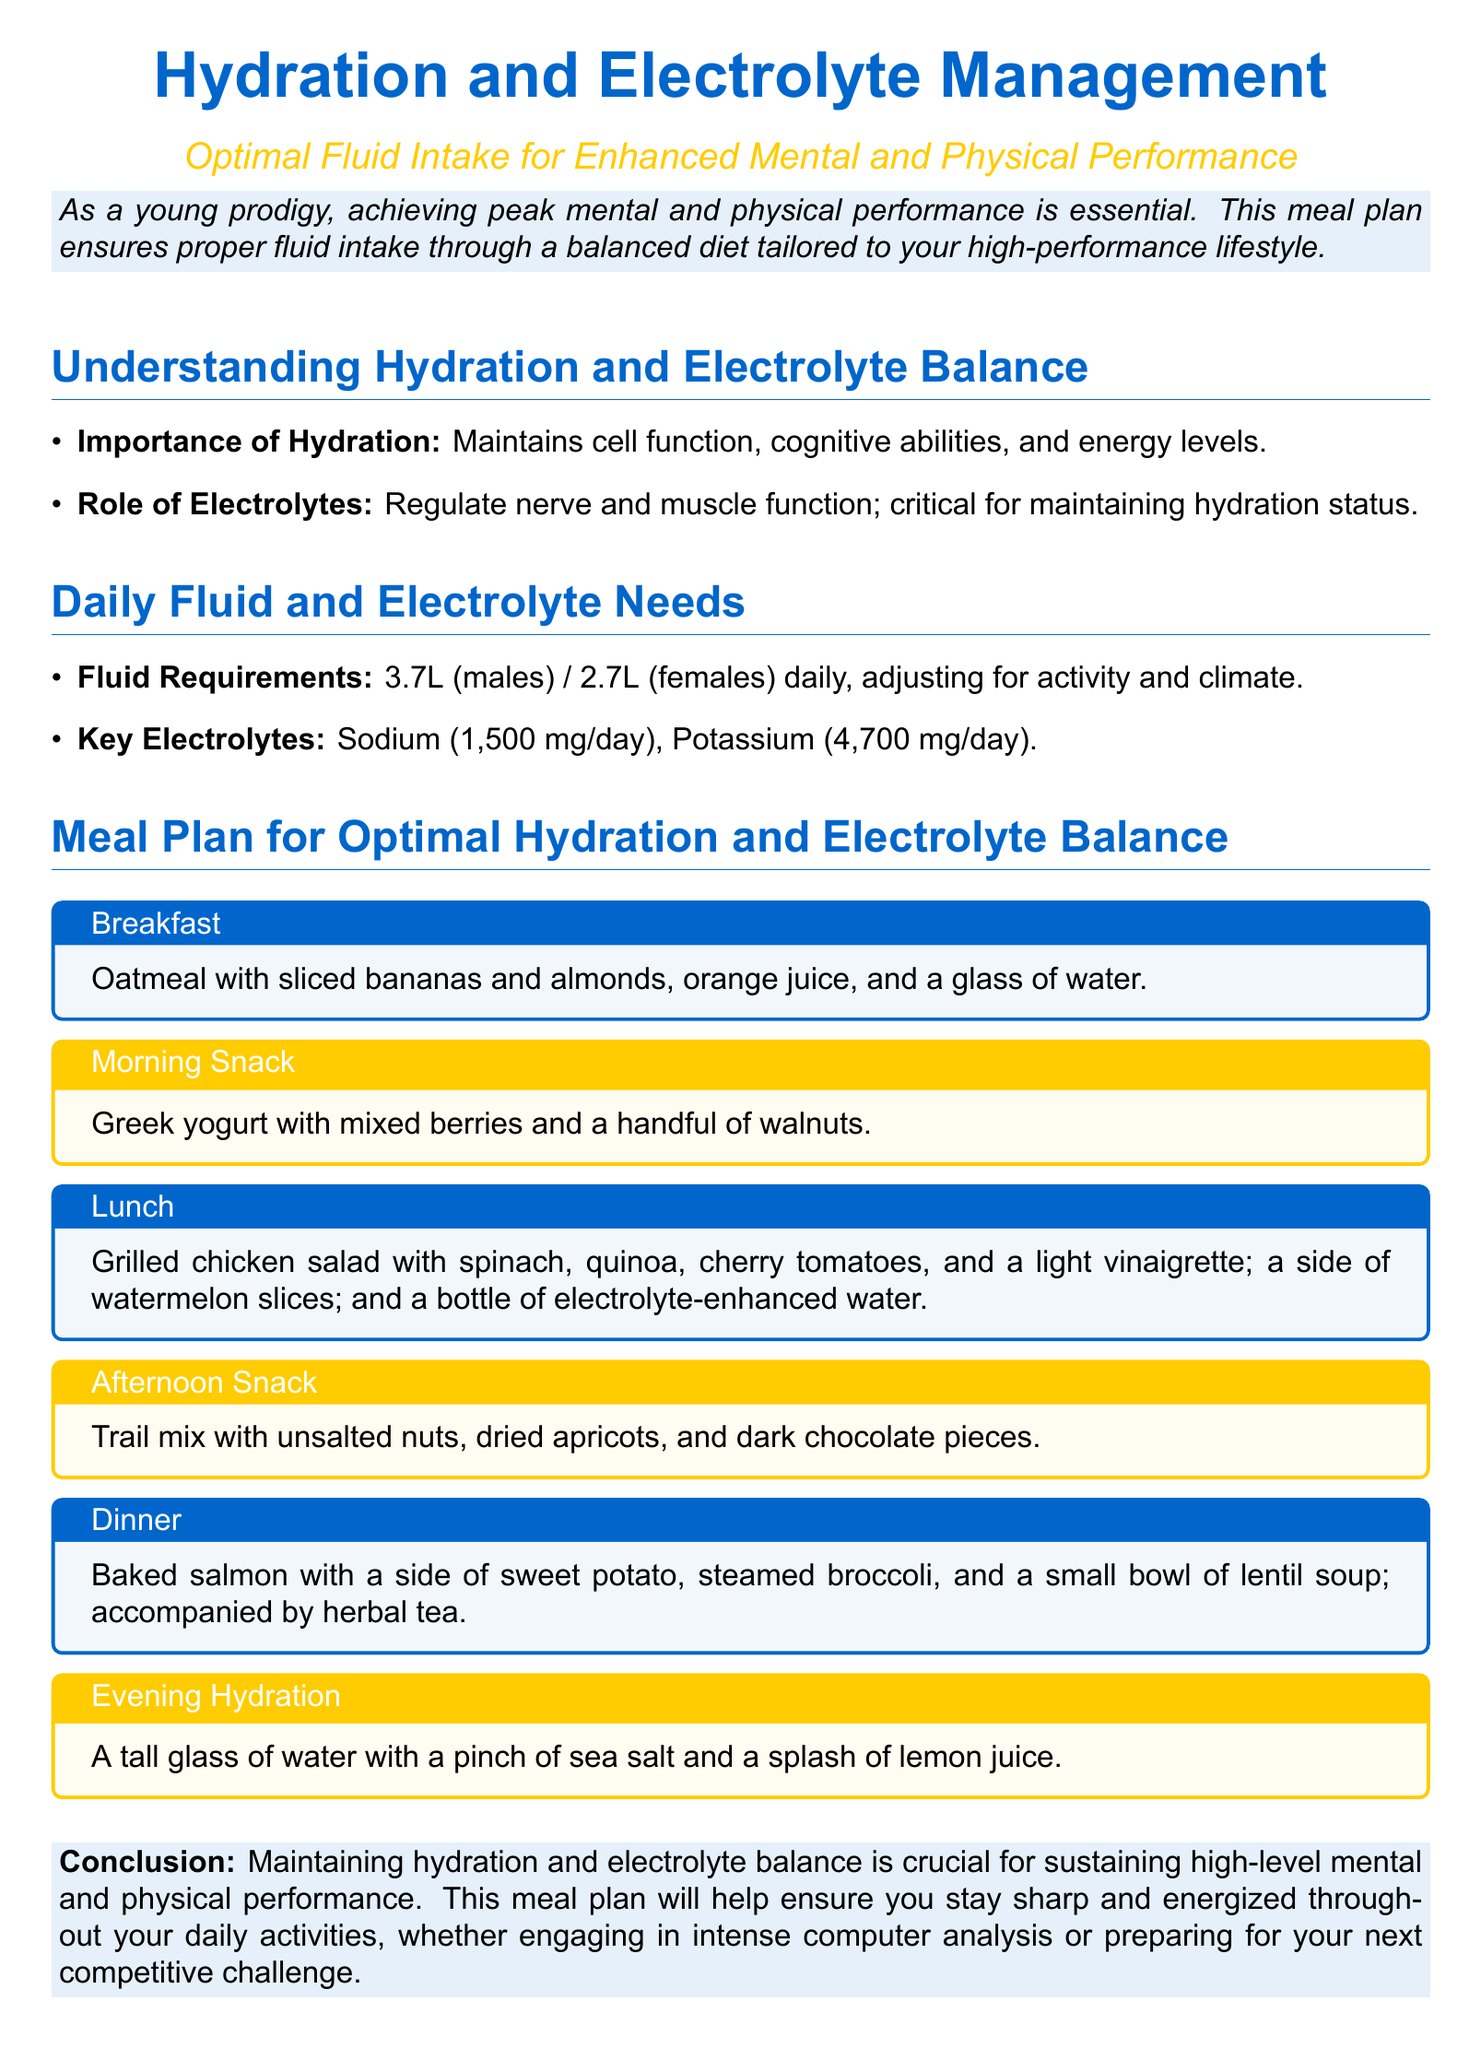What is the title of the meal plan? The title clearly stated at the beginning of the document is "Hydration and Electrolyte Management."
Answer: Hydration and Electrolyte Management What is the recommended daily fluid intake for males? The document specifies that males should aim for a fluid intake of 3.7 liters daily.
Answer: 3.7L What is one key electrolyte mentioned in the document? The document lists sodium and potassium as key electrolytes, with sodium being highlighted.
Answer: Sodium What does the breakfast meal consist of? The breakfast meal is outlined in the meal plan as oatmeal with sliced bananas and almonds, orange juice, and a glass of water.
Answer: Oatmeal with sliced bananas and almonds, orange juice, and a glass of water How much potassium is recommended per day? The daily requirement for potassium is stated explicitly in the document as 4,700 mg.
Answer: 4,700 mg What is suggested for afternoon snack? The document details that the afternoon snack consists of trail mix with unsalted nuts, dried apricots, and dark chocolate pieces.
Answer: Trail mix with unsalted nuts, dried apricots, and dark chocolate pieces What is the hydration recommendation for the evening? The evening hydration recommendation includes a tall glass of water with a pinch of sea salt and a splash of lemon juice.
Answer: A tall glass of water with a pinch of sea salt and a splash of lemon juice How is the dinner meal described in the plan? The dinner meal is a combination of baked salmon with a side of sweet potato, steamed broccoli, and a small bowl of lentil soup, along with herbal tea.
Answer: Baked salmon with a side of sweet potato, steamed broccoli, and lentil soup; herbal tea What is the significance of hydration according to the document? The document states that hydration maintains cell function, cognitive abilities, and energy levels.
Answer: Maintains cell function, cognitive abilities, and energy levels 